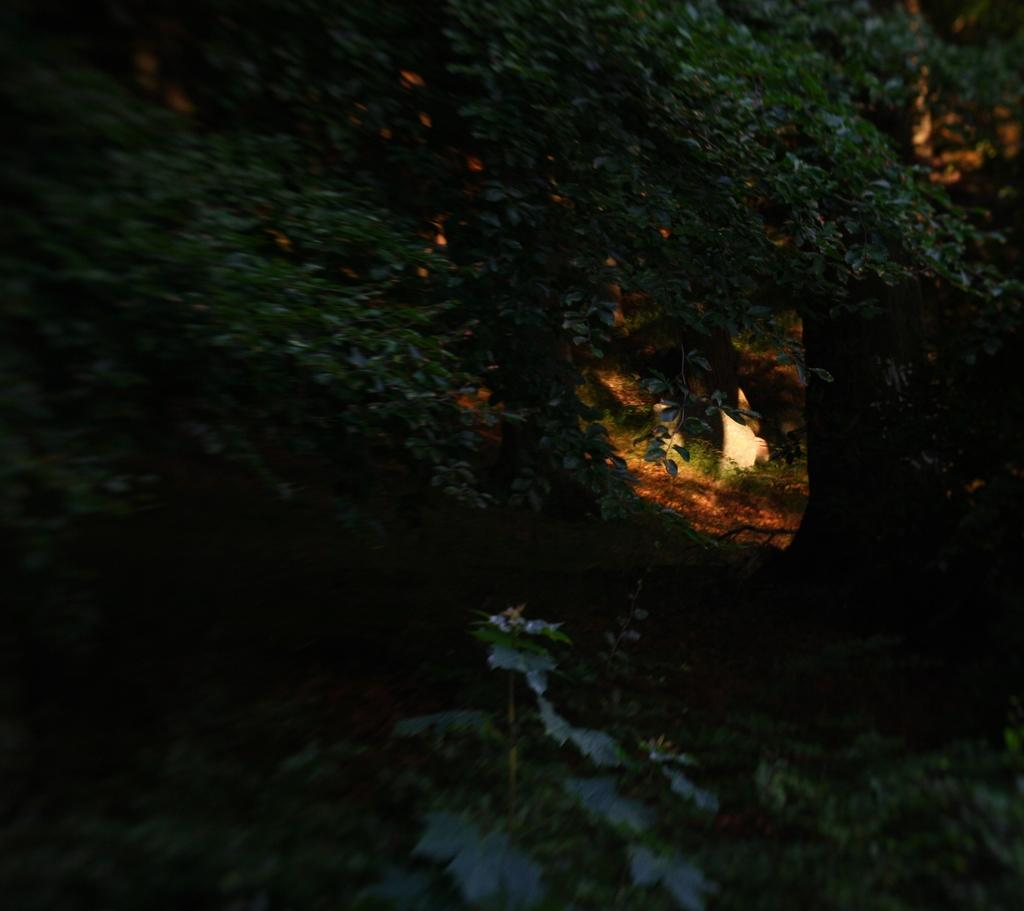What type of vegetation can be seen in the image? There are trees and plants visible in the image. Where are the trees and plants located? They are on the land in the image. What else can be seen on the land in the image? There is a light visible on a path in the image. How many girls are shaking the trees in the image? There are no girls present in the image, and the trees are not being shaken. 